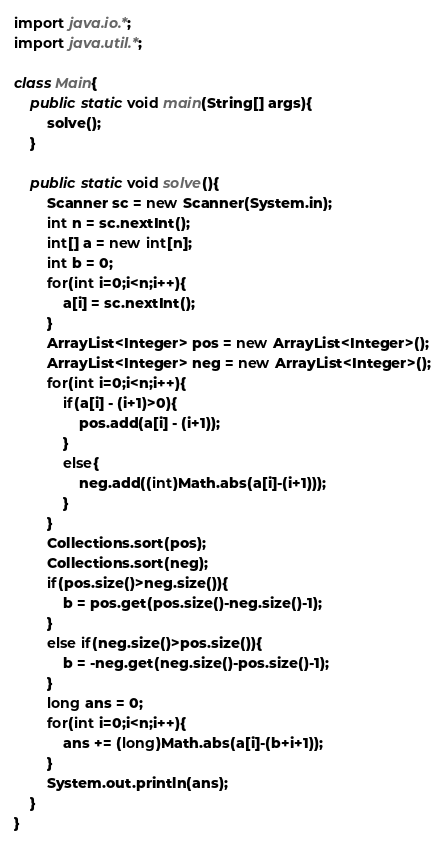<code> <loc_0><loc_0><loc_500><loc_500><_Java_>
import java.io.*;
import java.util.*;

class Main{
    public static void main(String[] args){
        solve();
    }

    public static void solve(){
        Scanner sc = new Scanner(System.in);
     	int n = sc.nextInt();
     	int[] a = new int[n];
     	int b = 0;
     	for(int i=0;i<n;i++){
     		a[i] = sc.nextInt();
     	}   
     	ArrayList<Integer> pos = new ArrayList<Integer>();
     	ArrayList<Integer> neg = new ArrayList<Integer>();
     	for(int i=0;i<n;i++){
     		if(a[i] - (i+1)>0){
     			pos.add(a[i] - (i+1));
     		}
     		else{
     			neg.add((int)Math.abs(a[i]-(i+1)));
     		}
     	}
     	Collections.sort(pos);
     	Collections.sort(neg);
     	if(pos.size()>neg.size()){
     		b = pos.get(pos.size()-neg.size()-1);
     	}
     	else if(neg.size()>pos.size()){
     		b = -neg.get(neg.size()-pos.size()-1);
     	}
     	long ans = 0;
     	for(int i=0;i<n;i++){
     		ans += (long)Math.abs(a[i]-(b+i+1));
     	}
     	System.out.println(ans);
    }
}</code> 